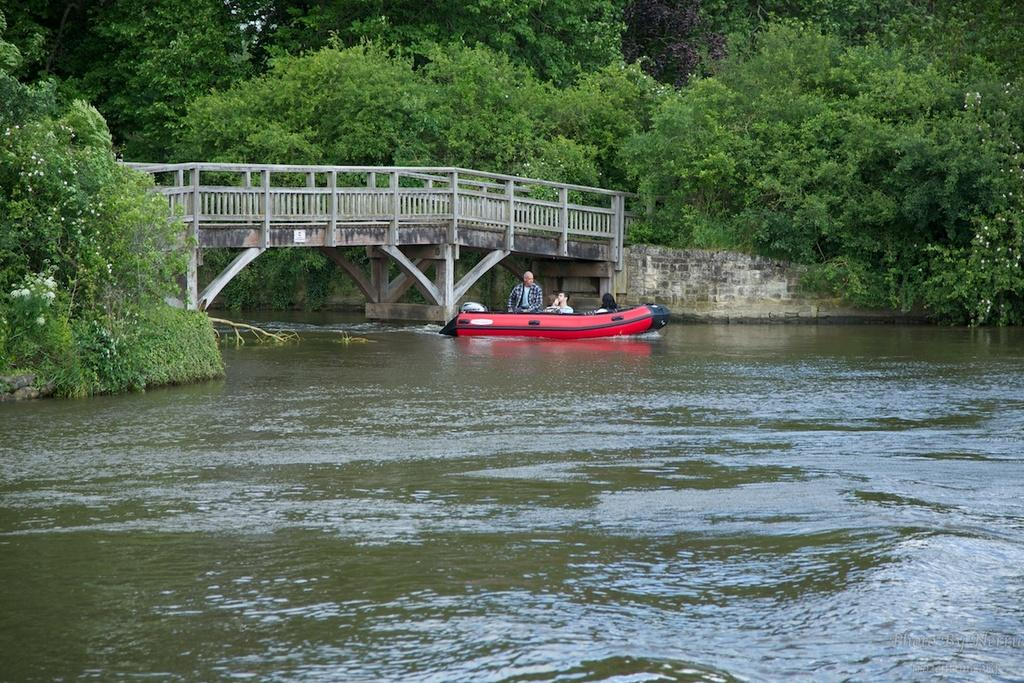What are the people in the image doing? The people in the image are on a boat. Where is the boat located? The boat is on the water. What structures can be seen in the image? There is a bridge and a wall in the image. What safety features are present on the boat? There are railings on the boat. What can be seen in the background of the image? There are trees and plants with flowers in the background of the image. What type of birthday celebration is taking place on the boat in the image? There is no indication of a birthday celebration in the image; it simply shows people on a boat. How does the battle between the two boats in the image affect the bridge? There are no boats engaged in a battle in the image, and the bridge is not affected. 